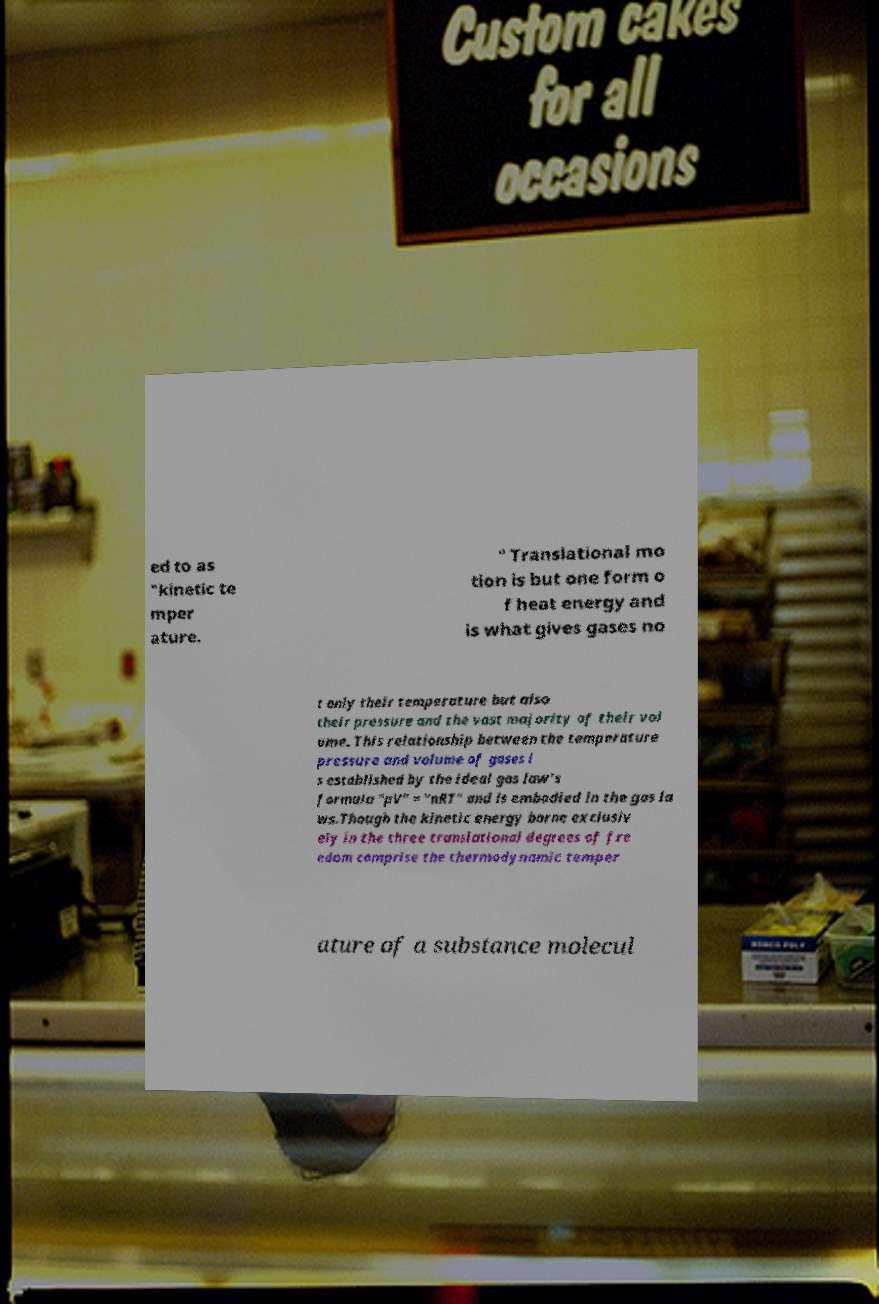Could you assist in decoding the text presented in this image and type it out clearly? ed to as "kinetic te mper ature. " Translational mo tion is but one form o f heat energy and is what gives gases no t only their temperature but also their pressure and the vast majority of their vol ume. This relationship between the temperature pressure and volume of gases i s established by the ideal gas law's formula "pV" = "nRT" and is embodied in the gas la ws.Though the kinetic energy borne exclusiv ely in the three translational degrees of fre edom comprise the thermodynamic temper ature of a substance molecul 